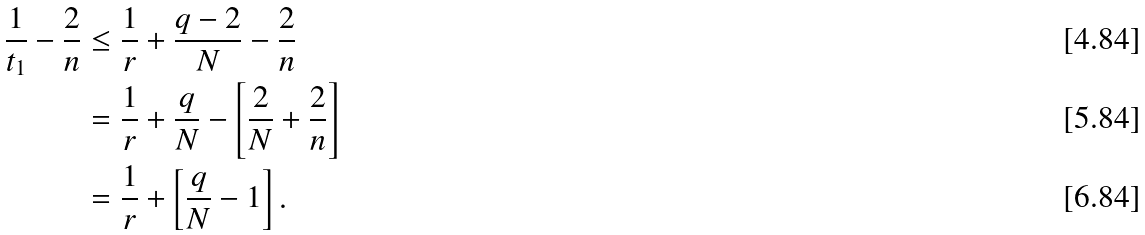Convert formula to latex. <formula><loc_0><loc_0><loc_500><loc_500>\frac { 1 } { t _ { 1 } } - \frac { 2 } { n } & \leq \frac { 1 } { r } + \frac { q - 2 } { N } - \frac { 2 } { n } \\ & = \frac { 1 } { r } + \frac { q } { N } - \left [ \frac { 2 } { N } + \frac { 2 } { n } \right ] \\ & = \frac { 1 } { r } + \left [ \frac { q } { N } - 1 \right ] .</formula> 